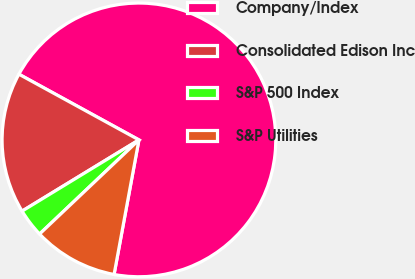Convert chart. <chart><loc_0><loc_0><loc_500><loc_500><pie_chart><fcel>Company/Index<fcel>Consolidated Edison Inc<fcel>S&P 500 Index<fcel>S&P Utilities<nl><fcel>69.93%<fcel>16.68%<fcel>3.36%<fcel>10.02%<nl></chart> 